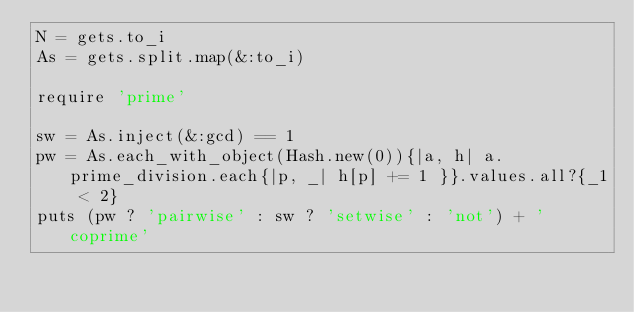<code> <loc_0><loc_0><loc_500><loc_500><_Ruby_>N = gets.to_i
As = gets.split.map(&:to_i)

require 'prime'

sw = As.inject(&:gcd) == 1
pw = As.each_with_object(Hash.new(0)){|a, h| a.prime_division.each{|p, _| h[p] += 1 }}.values.all?{_1 < 2}
puts (pw ? 'pairwise' : sw ? 'setwise' : 'not') + ' coprime'</code> 